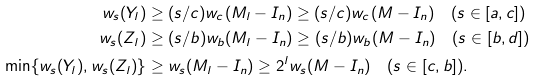Convert formula to latex. <formula><loc_0><loc_0><loc_500><loc_500>w _ { s } ( Y _ { l } ) & \geq ( s / c ) w _ { c } ( M _ { l } - I _ { n } ) \geq ( s / c ) w _ { c } ( M - I _ { n } ) \quad ( s \in [ a , c ] ) \\ w _ { s } ( Z _ { l } ) & \geq ( s / b ) w _ { b } ( M _ { l } - I _ { n } ) \geq ( s / b ) w _ { b } ( M - I _ { n } ) \quad ( s \in [ b , d ] ) \\ \min \{ w _ { s } ( Y _ { l } ) , w _ { s } ( Z _ { l } ) \} & \geq w _ { s } ( M _ { l } - I _ { n } ) \geq 2 ^ { l } w _ { s } ( M - I _ { n } ) \quad ( s \in [ c , b ] ) .</formula> 